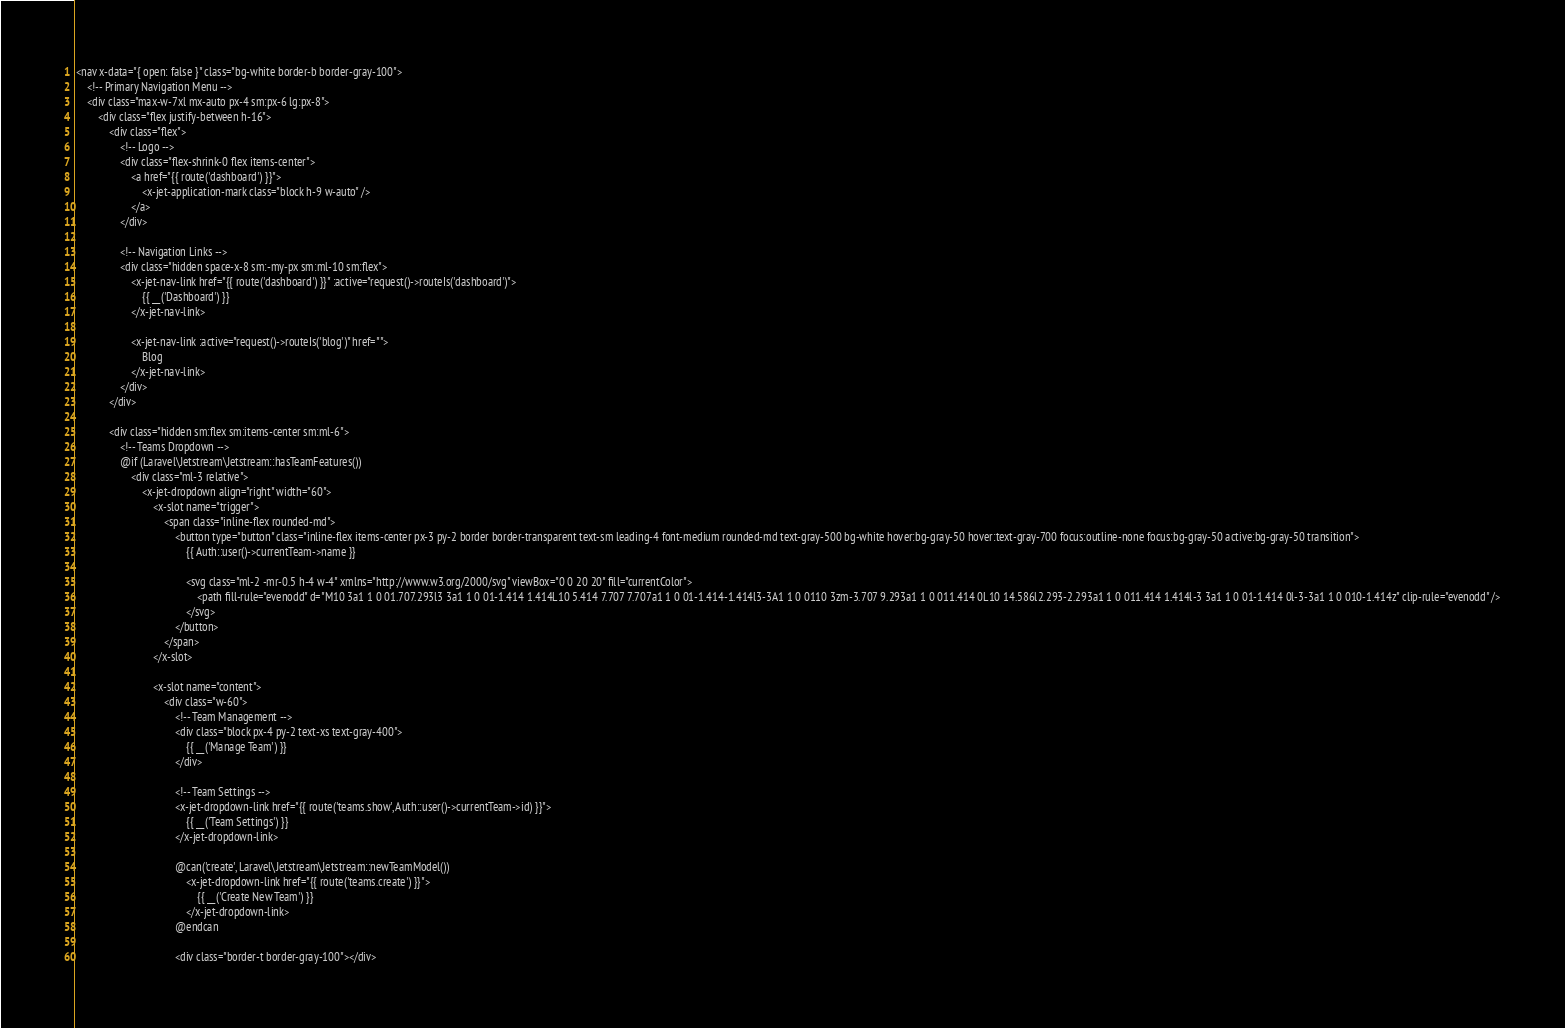Convert code to text. <code><loc_0><loc_0><loc_500><loc_500><_PHP_><nav x-data="{ open: false }" class="bg-white border-b border-gray-100">
    <!-- Primary Navigation Menu -->
    <div class="max-w-7xl mx-auto px-4 sm:px-6 lg:px-8">
        <div class="flex justify-between h-16">
            <div class="flex">
                <!-- Logo -->
                <div class="flex-shrink-0 flex items-center">
                    <a href="{{ route('dashboard') }}">
                        <x-jet-application-mark class="block h-9 w-auto" />
                    </a>
                </div>

                <!-- Navigation Links -->
                <div class="hidden space-x-8 sm:-my-px sm:ml-10 sm:flex">
                    <x-jet-nav-link href="{{ route('dashboard') }}" :active="request()->routeIs('dashboard')">
                        {{ __('Dashboard') }}
                    </x-jet-nav-link>

                    <x-jet-nav-link :active="request()->routeIs('blog')" href="">
                        Blog
                    </x-jet-nav-link>
                </div>
            </div>

            <div class="hidden sm:flex sm:items-center sm:ml-6">
                <!-- Teams Dropdown -->
                @if (Laravel\Jetstream\Jetstream::hasTeamFeatures())
                    <div class="ml-3 relative">
                        <x-jet-dropdown align="right" width="60">
                            <x-slot name="trigger">
                                <span class="inline-flex rounded-md">
                                    <button type="button" class="inline-flex items-center px-3 py-2 border border-transparent text-sm leading-4 font-medium rounded-md text-gray-500 bg-white hover:bg-gray-50 hover:text-gray-700 focus:outline-none focus:bg-gray-50 active:bg-gray-50 transition">
                                        {{ Auth::user()->currentTeam->name }}

                                        <svg class="ml-2 -mr-0.5 h-4 w-4" xmlns="http://www.w3.org/2000/svg" viewBox="0 0 20 20" fill="currentColor">
                                            <path fill-rule="evenodd" d="M10 3a1 1 0 01.707.293l3 3a1 1 0 01-1.414 1.414L10 5.414 7.707 7.707a1 1 0 01-1.414-1.414l3-3A1 1 0 0110 3zm-3.707 9.293a1 1 0 011.414 0L10 14.586l2.293-2.293a1 1 0 011.414 1.414l-3 3a1 1 0 01-1.414 0l-3-3a1 1 0 010-1.414z" clip-rule="evenodd" />
                                        </svg>
                                    </button>
                                </span>
                            </x-slot>

                            <x-slot name="content">
                                <div class="w-60">
                                    <!-- Team Management -->
                                    <div class="block px-4 py-2 text-xs text-gray-400">
                                        {{ __('Manage Team') }}
                                    </div>

                                    <!-- Team Settings -->
                                    <x-jet-dropdown-link href="{{ route('teams.show', Auth::user()->currentTeam->id) }}">
                                        {{ __('Team Settings') }}
                                    </x-jet-dropdown-link>

                                    @can('create', Laravel\Jetstream\Jetstream::newTeamModel())
                                        <x-jet-dropdown-link href="{{ route('teams.create') }}">
                                            {{ __('Create New Team') }}
                                        </x-jet-dropdown-link>
                                    @endcan

                                    <div class="border-t border-gray-100"></div>
</code> 